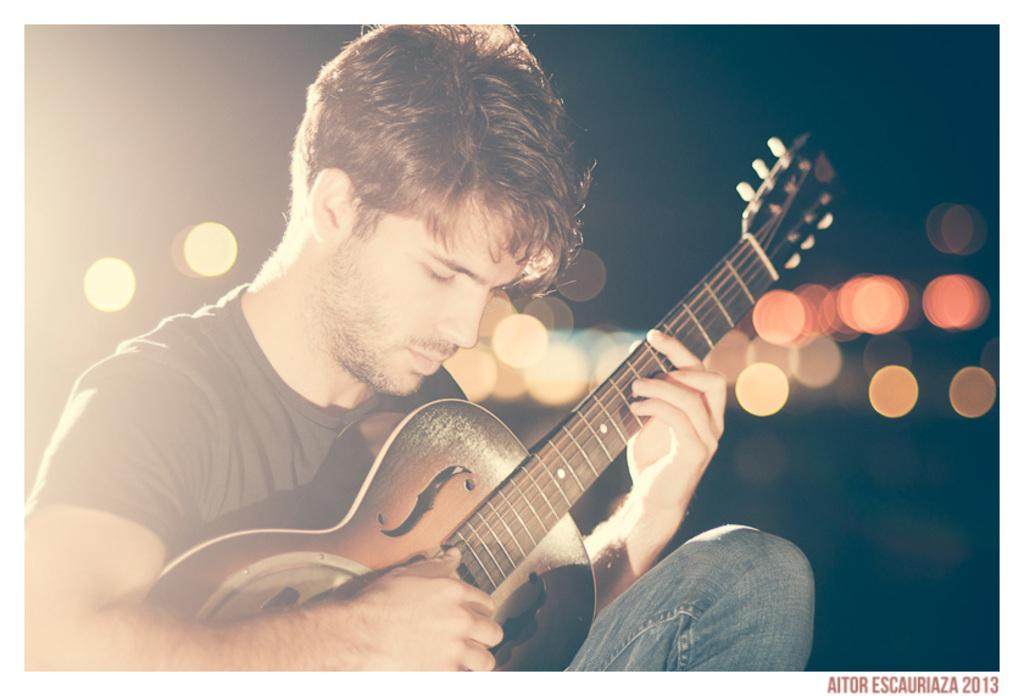What is the man in the image doing? The man in the image is playing a guitar. Can you describe the setting of the image? There are lights visible behind the man. Where is the cactus located in the image? There is no cactus present in the image. What type of animal is the man riding in the image? There is no animal, such as a donkey, present in the image. 